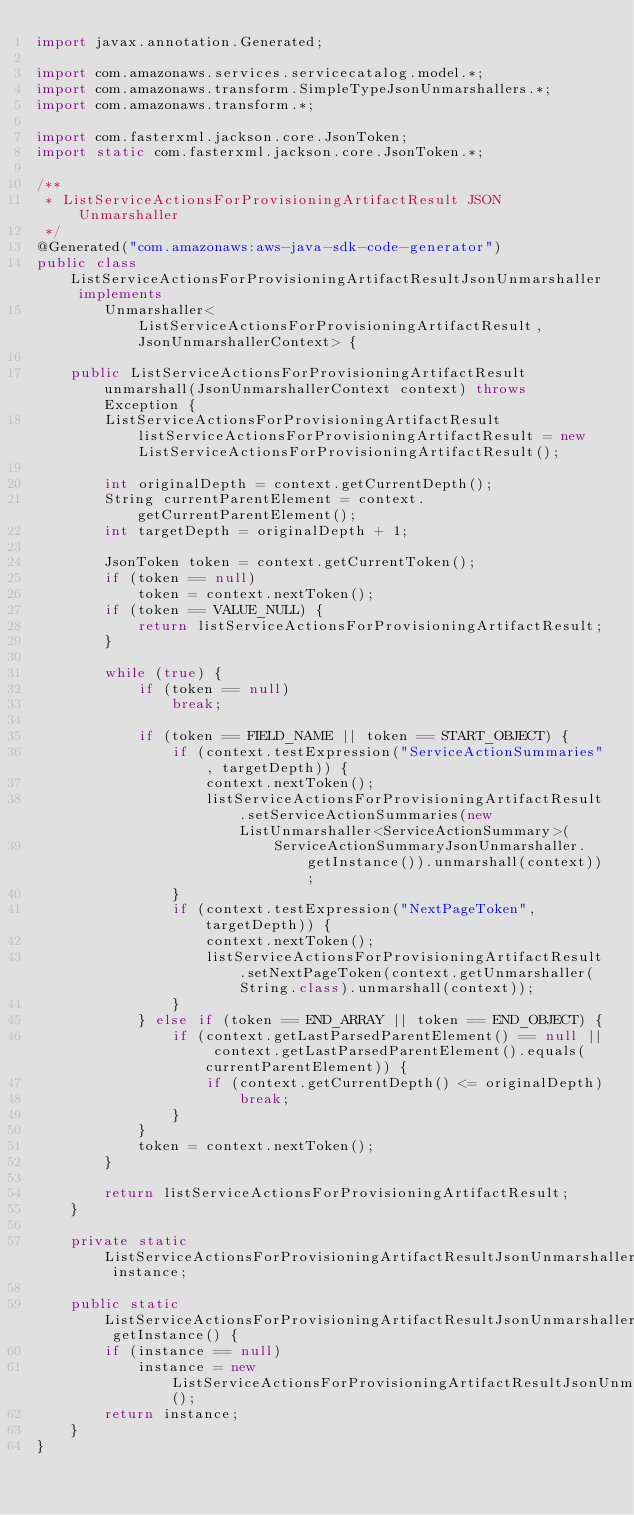Convert code to text. <code><loc_0><loc_0><loc_500><loc_500><_Java_>import javax.annotation.Generated;

import com.amazonaws.services.servicecatalog.model.*;
import com.amazonaws.transform.SimpleTypeJsonUnmarshallers.*;
import com.amazonaws.transform.*;

import com.fasterxml.jackson.core.JsonToken;
import static com.fasterxml.jackson.core.JsonToken.*;

/**
 * ListServiceActionsForProvisioningArtifactResult JSON Unmarshaller
 */
@Generated("com.amazonaws:aws-java-sdk-code-generator")
public class ListServiceActionsForProvisioningArtifactResultJsonUnmarshaller implements
        Unmarshaller<ListServiceActionsForProvisioningArtifactResult, JsonUnmarshallerContext> {

    public ListServiceActionsForProvisioningArtifactResult unmarshall(JsonUnmarshallerContext context) throws Exception {
        ListServiceActionsForProvisioningArtifactResult listServiceActionsForProvisioningArtifactResult = new ListServiceActionsForProvisioningArtifactResult();

        int originalDepth = context.getCurrentDepth();
        String currentParentElement = context.getCurrentParentElement();
        int targetDepth = originalDepth + 1;

        JsonToken token = context.getCurrentToken();
        if (token == null)
            token = context.nextToken();
        if (token == VALUE_NULL) {
            return listServiceActionsForProvisioningArtifactResult;
        }

        while (true) {
            if (token == null)
                break;

            if (token == FIELD_NAME || token == START_OBJECT) {
                if (context.testExpression("ServiceActionSummaries", targetDepth)) {
                    context.nextToken();
                    listServiceActionsForProvisioningArtifactResult.setServiceActionSummaries(new ListUnmarshaller<ServiceActionSummary>(
                            ServiceActionSummaryJsonUnmarshaller.getInstance()).unmarshall(context));
                }
                if (context.testExpression("NextPageToken", targetDepth)) {
                    context.nextToken();
                    listServiceActionsForProvisioningArtifactResult.setNextPageToken(context.getUnmarshaller(String.class).unmarshall(context));
                }
            } else if (token == END_ARRAY || token == END_OBJECT) {
                if (context.getLastParsedParentElement() == null || context.getLastParsedParentElement().equals(currentParentElement)) {
                    if (context.getCurrentDepth() <= originalDepth)
                        break;
                }
            }
            token = context.nextToken();
        }

        return listServiceActionsForProvisioningArtifactResult;
    }

    private static ListServiceActionsForProvisioningArtifactResultJsonUnmarshaller instance;

    public static ListServiceActionsForProvisioningArtifactResultJsonUnmarshaller getInstance() {
        if (instance == null)
            instance = new ListServiceActionsForProvisioningArtifactResultJsonUnmarshaller();
        return instance;
    }
}
</code> 